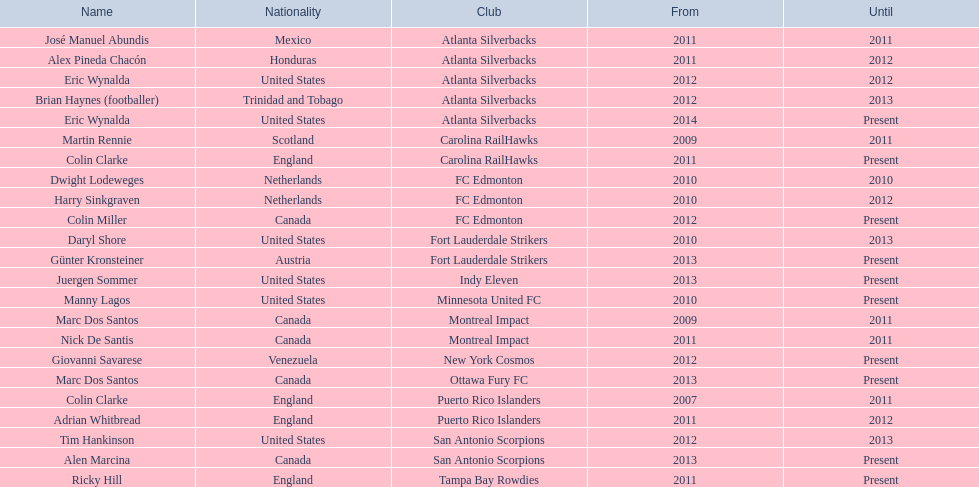In what year did marc dos santos initiate his coaching position? 2009. Which other inception years align with this year? 2009. Who was the other coach with this commencing year? Martin Rennie. 